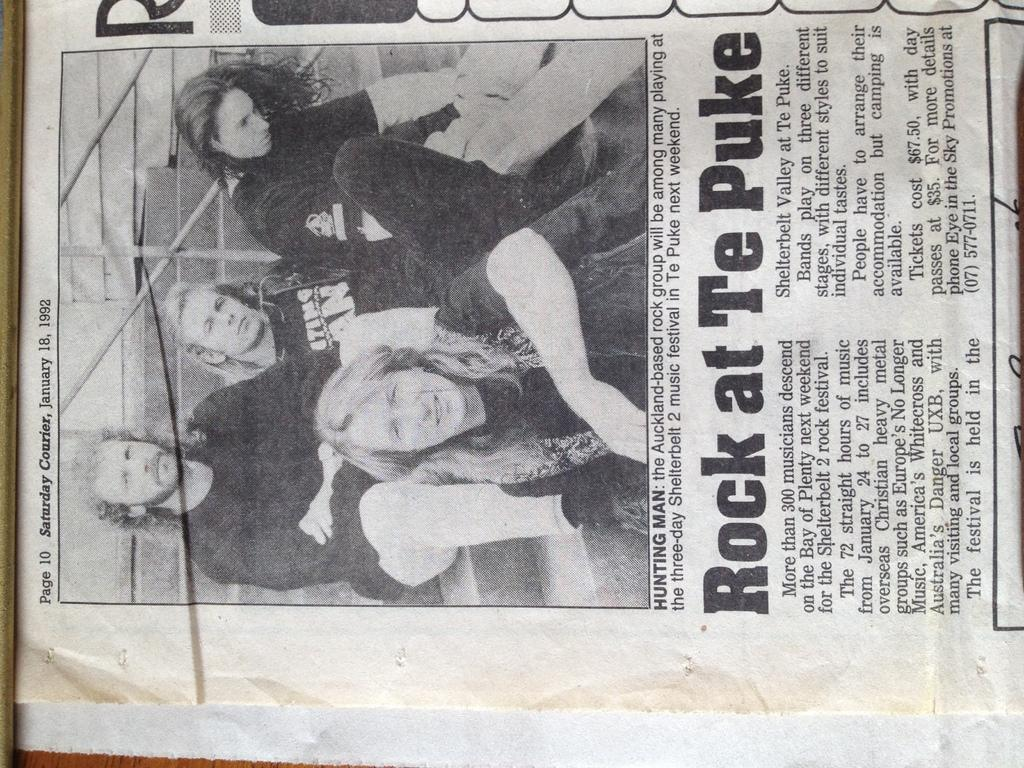What is the main subject of the image? The main subject of the image is an article on paper. Can you describe the people in the image? There is a group of people in the image. What can be read on the paper in the image? There is text written on the paper in the image. How many sheep are visible in the image? There are no sheep present in the image. What type of disease is mentioned in the text on the paper? We cannot determine the content of the text on the paper from the image alone, so we cannot answer this question. 